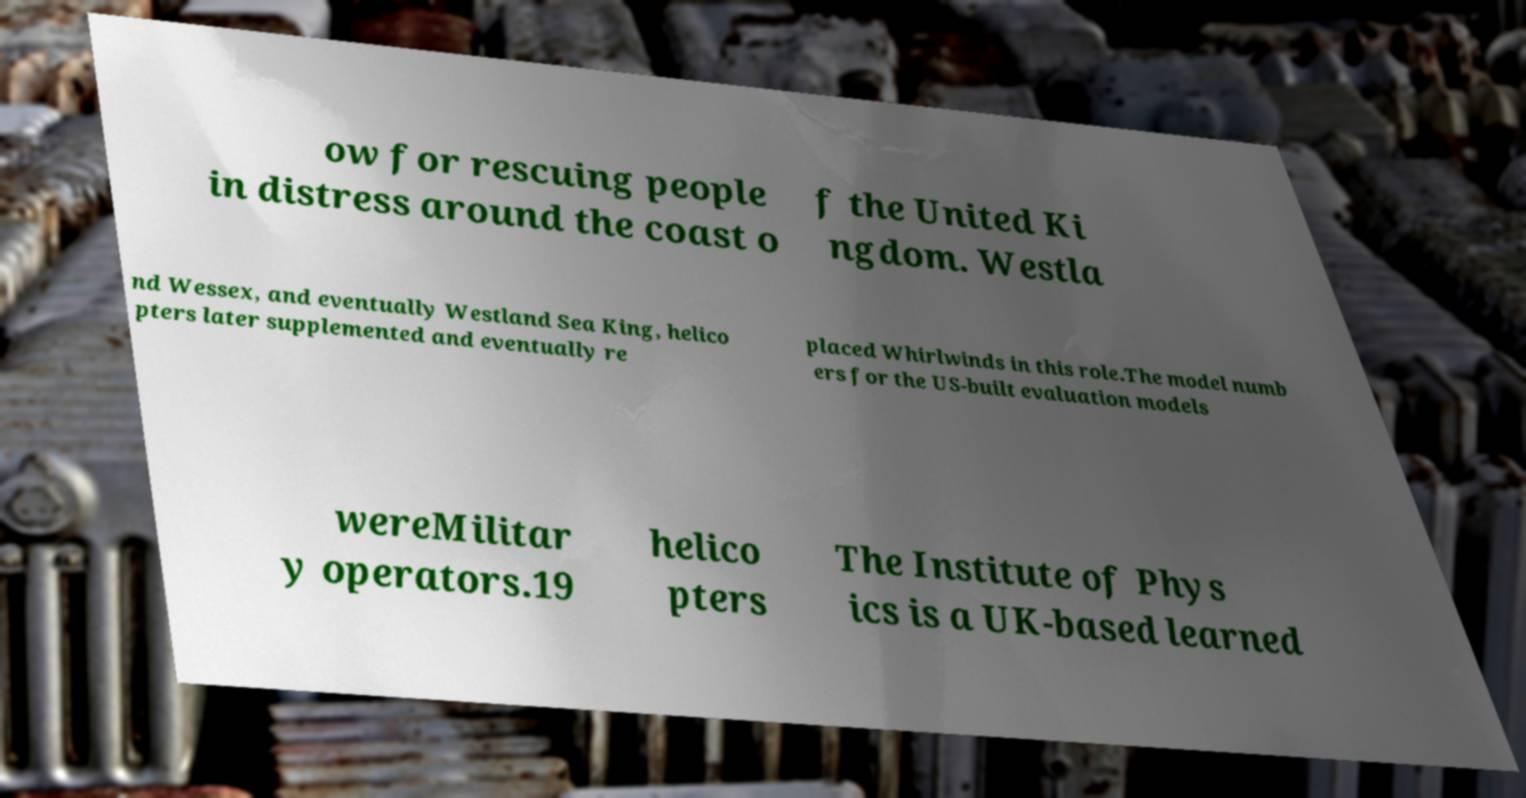There's text embedded in this image that I need extracted. Can you transcribe it verbatim? ow for rescuing people in distress around the coast o f the United Ki ngdom. Westla nd Wessex, and eventually Westland Sea King, helico pters later supplemented and eventually re placed Whirlwinds in this role.The model numb ers for the US-built evaluation models wereMilitar y operators.19 helico pters The Institute of Phys ics is a UK-based learned 